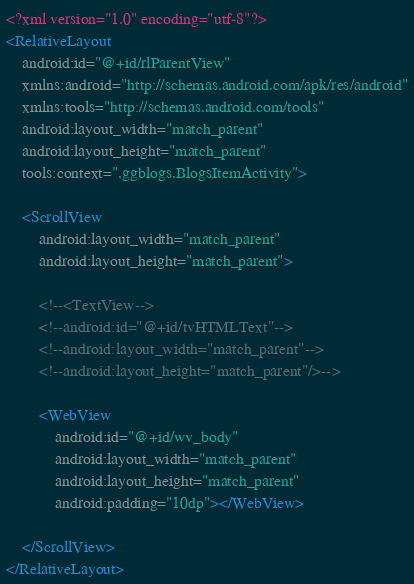<code> <loc_0><loc_0><loc_500><loc_500><_XML_><?xml version="1.0" encoding="utf-8"?>
<RelativeLayout
    android:id="@+id/rlParentView"
    xmlns:android="http://schemas.android.com/apk/res/android"
    xmlns:tools="http://schemas.android.com/tools"
    android:layout_width="match_parent"
    android:layout_height="match_parent"
    tools:context=".ggblogs.BlogsItemActivity">

    <ScrollView
        android:layout_width="match_parent"
        android:layout_height="match_parent">

        <!--<TextView-->
        <!--android:id="@+id/tvHTMLText"-->
        <!--android:layout_width="match_parent"-->
        <!--android:layout_height="match_parent"/>-->

        <WebView
            android:id="@+id/wv_body"
            android:layout_width="match_parent"
            android:layout_height="match_parent"
            android:padding="10dp"></WebView>

    </ScrollView>
</RelativeLayout>
</code> 